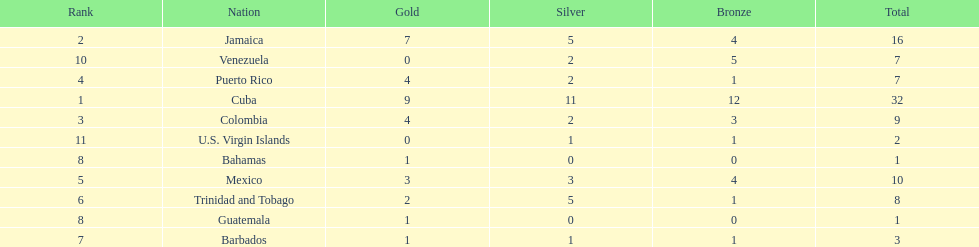What is the difference in medals between cuba and mexico? 22. Could you help me parse every detail presented in this table? {'header': ['Rank', 'Nation', 'Gold', 'Silver', 'Bronze', 'Total'], 'rows': [['2', 'Jamaica', '7', '5', '4', '16'], ['10', 'Venezuela', '0', '2', '5', '7'], ['4', 'Puerto Rico', '4', '2', '1', '7'], ['1', 'Cuba', '9', '11', '12', '32'], ['3', 'Colombia', '4', '2', '3', '9'], ['11', 'U.S. Virgin Islands', '0', '1', '1', '2'], ['8', 'Bahamas', '1', '0', '0', '1'], ['5', 'Mexico', '3', '3', '4', '10'], ['6', 'Trinidad and Tobago', '2', '5', '1', '8'], ['8', 'Guatemala', '1', '0', '0', '1'], ['7', 'Barbados', '1', '1', '1', '3']]} 